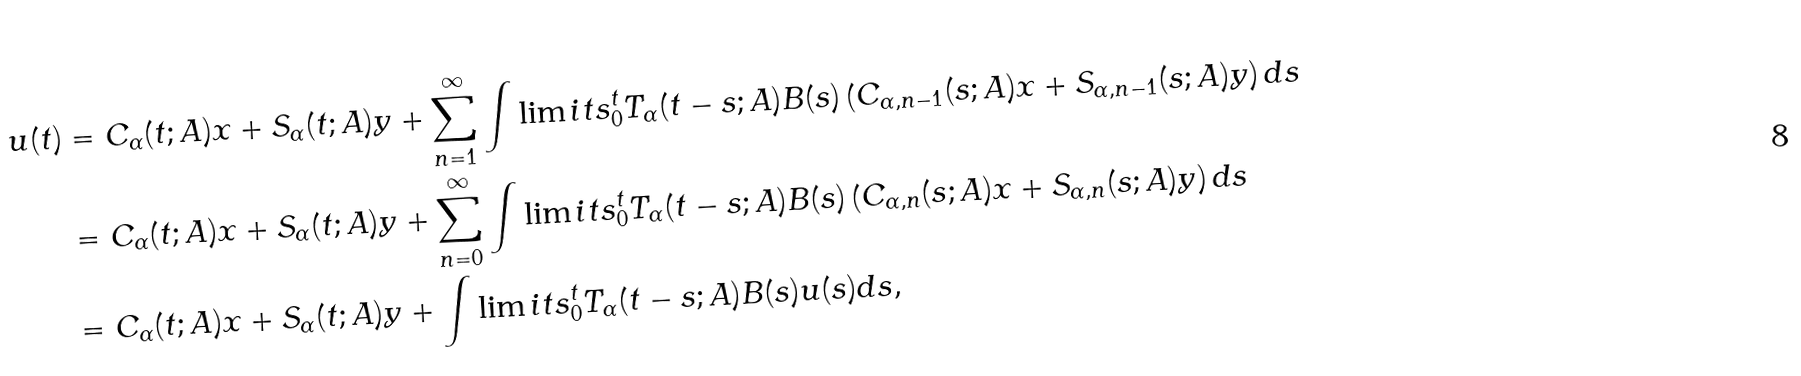Convert formula to latex. <formula><loc_0><loc_0><loc_500><loc_500>u ( t ) & = C _ { \alpha } ( t ; A ) x + S _ { \alpha } ( t ; A ) y + \sum _ { n = 1 } ^ { \infty } \int \lim i t s _ { 0 } ^ { t } T _ { \alpha } ( t - s ; A ) B ( s ) \left ( C _ { \alpha , n - 1 } ( s ; A ) x + S _ { \alpha , n - 1 } ( s ; A ) y \right ) d s \\ & = C _ { \alpha } ( t ; A ) x + S _ { \alpha } ( t ; A ) y + \sum _ { n = 0 } ^ { \infty } \int \lim i t s _ { 0 } ^ { t } T _ { \alpha } ( t - s ; A ) B ( s ) \left ( C _ { \alpha , n } ( s ; A ) x + S _ { \alpha , n } ( s ; A ) y \right ) d s \\ & = C _ { \alpha } ( t ; A ) x + S _ { \alpha } ( t ; A ) y + \int \lim i t s _ { 0 } ^ { t } T _ { \alpha } ( t - s ; A ) B ( s ) u ( s ) d s ,</formula> 